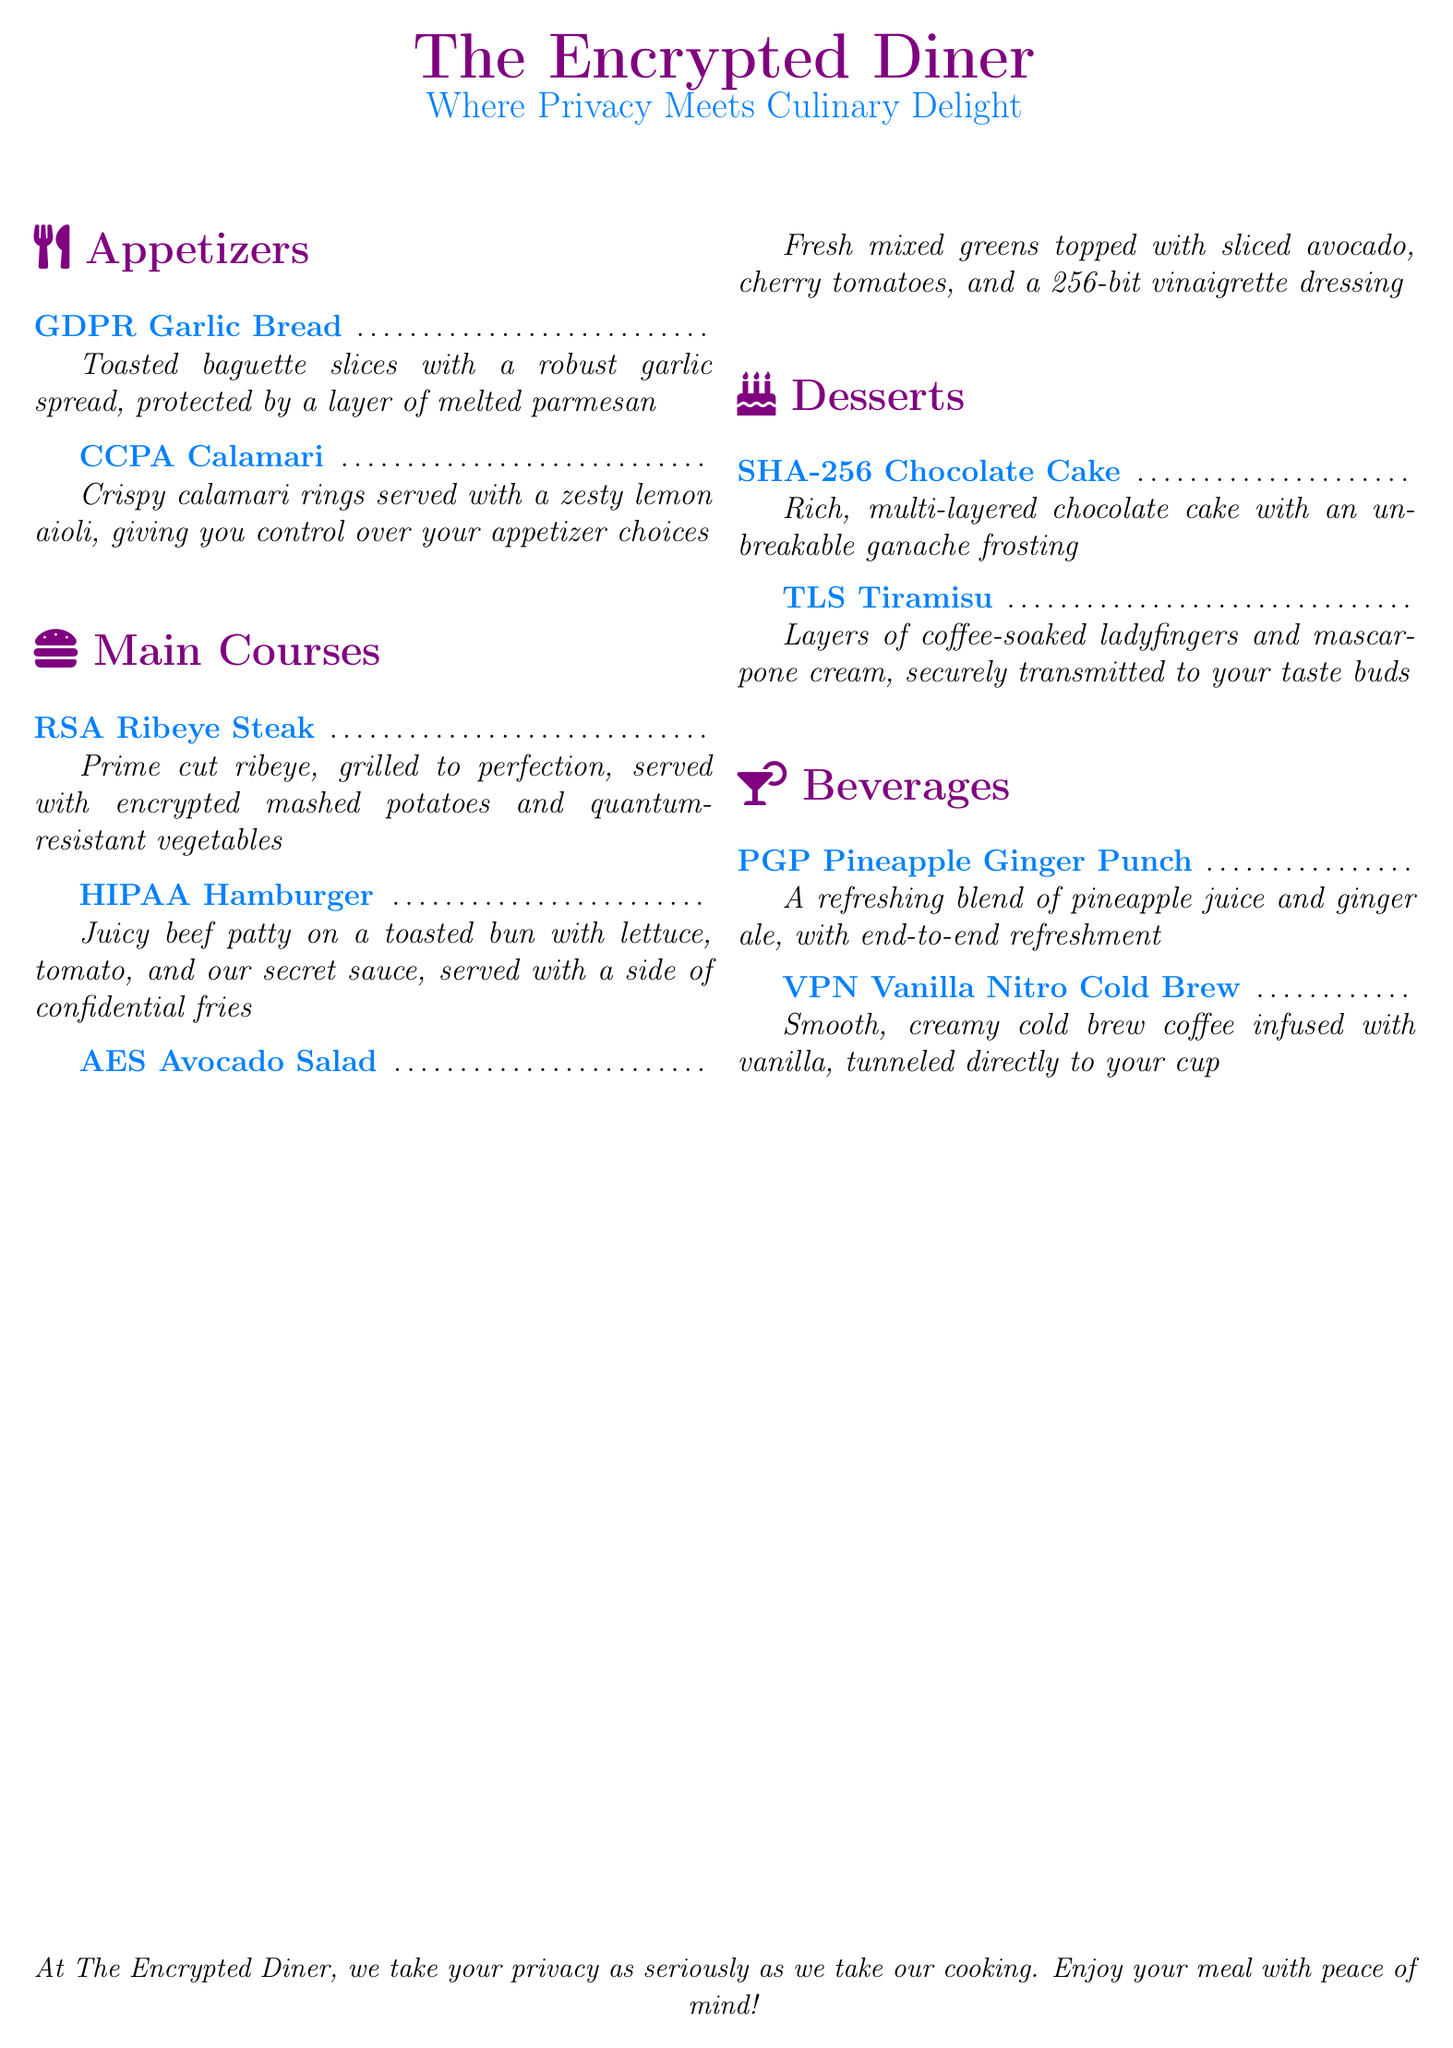What is the name of the restaurant? The title at the center of the document indicates the name of the restaurant is "The Encrypted Diner."
Answer: The Encrypted Diner What dish is named after a data protection law focusing on privacy rights? The appetizers section includes a dish named after the California Consumer Privacy Act.
Answer: CCPA Calamari What is the main ingredient in the GDPR Garlic Bread? The menu describes the main ingredient in the appetizer as a robust garlic spread.
Answer: Garlic spread How many main courses are listed on the menu? The main courses section contains four different dishes listed.
Answer: Four What is the dessert that features an unbreakable ganache frosting? The menu specifies that the SHA-256 Chocolate Cake has an unbreakable ganache frosting.
Answer: SHA-256 Chocolate Cake Which beverage includes ginger ale? The PGP Pineapple Ginger Punch has ginger ale as a key ingredient.
Answer: PGP Pineapple Ginger Punch What type of salad is offered as a main course? The menu states that the AES Avocado Salad is a fresh mixed greens salad.
Answer: AES Avocado Salad What is the description of the HIPAA Hamburger? The document details the HIPAA Hamburger as a juicy beef patty with lettuce, tomato, and secret sauce.
Answer: Juicy beef patty on a toasted bun What is a unique feature of the TLS Tiramisu? The TLS Tiramisu is noted for being securely transmitted to your taste buds.
Answer: Securely transmitted How does the VPN Vanilla Nitro Cold Brew get to your cup? The menu indicates that the VPN Vanilla Nitro Cold Brew is tunneled directly to your cup.
Answer: Tunneled directly to your cup 